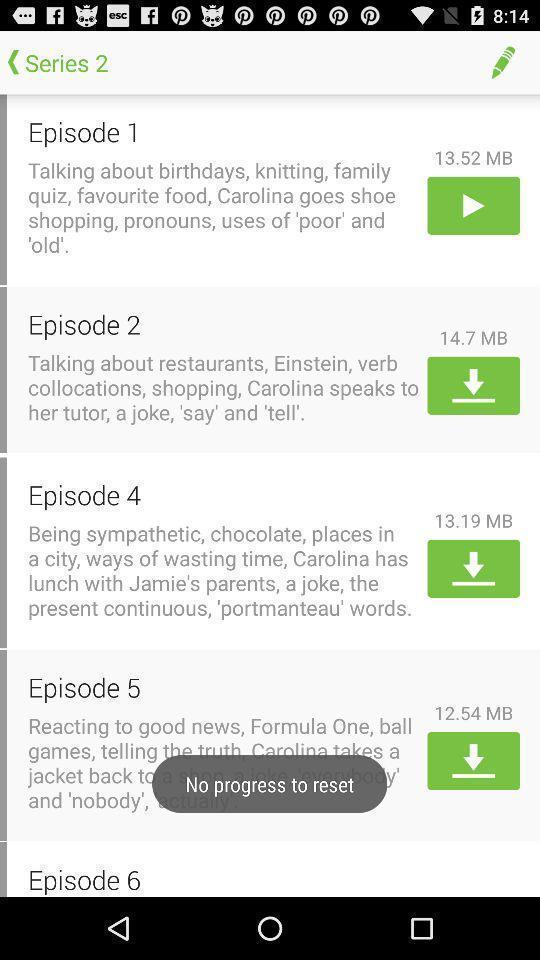Describe the key features of this screenshot. Screen displaying list of episodes. 